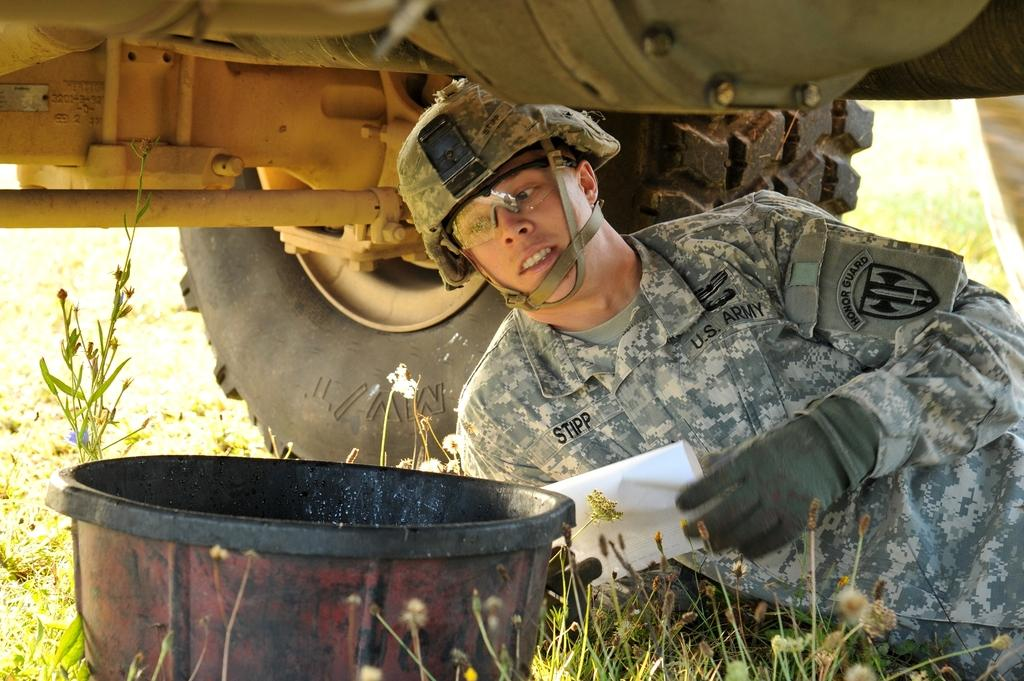What types of vegetation can be seen in the foreground of the picture? There are plants and grass in the foreground of the picture. What object is present in the foreground of the picture? There is a bucket in the foreground of the picture. Who is in the foreground of the picture? There is a soldier in uniform in the foreground of the picture. What is the soldier doing in the picture? The soldier is under a vehicle in the foreground of the picture. Can you describe the background of the image? The background of the image is blurred. What type of drain is visible in the picture? There is no drain present in the picture. How many cents are visible in the picture? There are no cents present in the picture. 